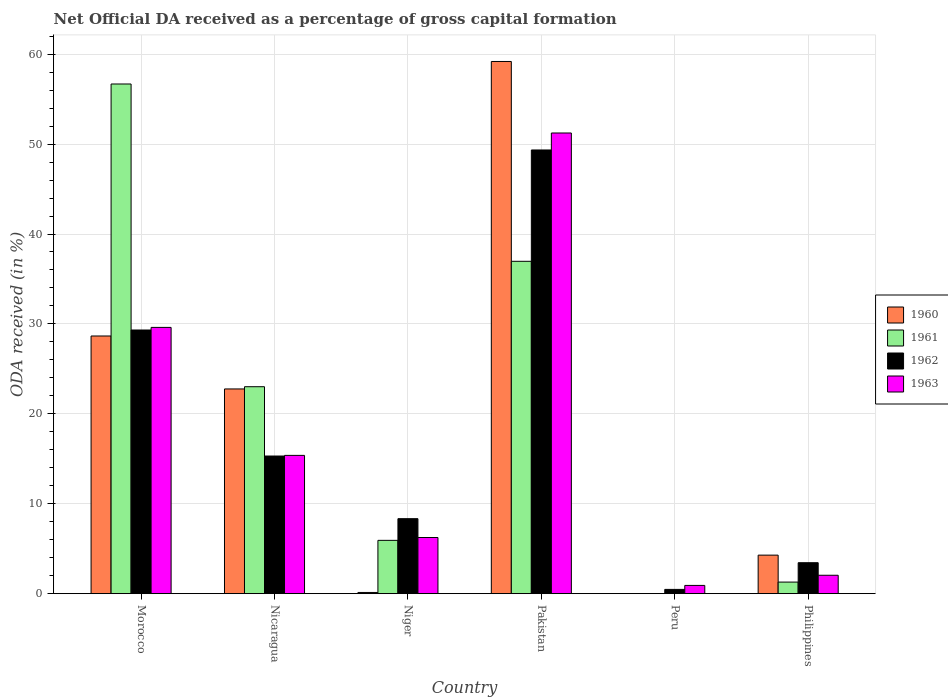How many different coloured bars are there?
Keep it short and to the point. 4. How many groups of bars are there?
Offer a very short reply. 6. How many bars are there on the 6th tick from the left?
Give a very brief answer. 4. How many bars are there on the 5th tick from the right?
Offer a very short reply. 4. What is the label of the 6th group of bars from the left?
Your answer should be compact. Philippines. What is the net ODA received in 1963 in Peru?
Ensure brevity in your answer.  0.92. Across all countries, what is the maximum net ODA received in 1960?
Give a very brief answer. 59.19. Across all countries, what is the minimum net ODA received in 1963?
Give a very brief answer. 0.92. In which country was the net ODA received in 1961 maximum?
Ensure brevity in your answer.  Morocco. What is the total net ODA received in 1962 in the graph?
Your answer should be compact. 106.24. What is the difference between the net ODA received in 1962 in Morocco and that in Niger?
Offer a very short reply. 20.98. What is the difference between the net ODA received in 1960 in Morocco and the net ODA received in 1963 in Nicaragua?
Provide a short and direct response. 13.28. What is the average net ODA received in 1962 per country?
Offer a very short reply. 17.71. What is the difference between the net ODA received of/in 1963 and net ODA received of/in 1960 in Pakistan?
Keep it short and to the point. -7.95. What is the ratio of the net ODA received in 1960 in Nicaragua to that in Pakistan?
Provide a short and direct response. 0.38. Is the difference between the net ODA received in 1963 in Nicaragua and Philippines greater than the difference between the net ODA received in 1960 in Nicaragua and Philippines?
Offer a terse response. No. What is the difference between the highest and the second highest net ODA received in 1960?
Your answer should be very brief. 30.53. What is the difference between the highest and the lowest net ODA received in 1961?
Your answer should be very brief. 56.69. Is it the case that in every country, the sum of the net ODA received in 1960 and net ODA received in 1963 is greater than the sum of net ODA received in 1962 and net ODA received in 1961?
Your response must be concise. No. Are all the bars in the graph horizontal?
Provide a short and direct response. No. How many countries are there in the graph?
Your response must be concise. 6. Does the graph contain any zero values?
Your answer should be compact. Yes. How are the legend labels stacked?
Your response must be concise. Vertical. What is the title of the graph?
Offer a terse response. Net Official DA received as a percentage of gross capital formation. What is the label or title of the X-axis?
Offer a terse response. Country. What is the label or title of the Y-axis?
Provide a succinct answer. ODA received (in %). What is the ODA received (in %) in 1960 in Morocco?
Give a very brief answer. 28.66. What is the ODA received (in %) of 1961 in Morocco?
Offer a very short reply. 56.69. What is the ODA received (in %) of 1962 in Morocco?
Your answer should be compact. 29.32. What is the ODA received (in %) in 1963 in Morocco?
Keep it short and to the point. 29.61. What is the ODA received (in %) in 1960 in Nicaragua?
Your response must be concise. 22.77. What is the ODA received (in %) of 1961 in Nicaragua?
Offer a very short reply. 23.02. What is the ODA received (in %) in 1962 in Nicaragua?
Give a very brief answer. 15.31. What is the ODA received (in %) in 1963 in Nicaragua?
Give a very brief answer. 15.38. What is the ODA received (in %) in 1960 in Niger?
Offer a very short reply. 0.13. What is the ODA received (in %) of 1961 in Niger?
Provide a succinct answer. 5.93. What is the ODA received (in %) in 1962 in Niger?
Your answer should be compact. 8.34. What is the ODA received (in %) in 1963 in Niger?
Provide a short and direct response. 6.25. What is the ODA received (in %) of 1960 in Pakistan?
Make the answer very short. 59.19. What is the ODA received (in %) of 1961 in Pakistan?
Offer a terse response. 36.96. What is the ODA received (in %) in 1962 in Pakistan?
Provide a succinct answer. 49.35. What is the ODA received (in %) in 1963 in Pakistan?
Make the answer very short. 51.24. What is the ODA received (in %) in 1961 in Peru?
Provide a short and direct response. 0. What is the ODA received (in %) of 1962 in Peru?
Make the answer very short. 0.47. What is the ODA received (in %) of 1963 in Peru?
Your answer should be very brief. 0.92. What is the ODA received (in %) of 1960 in Philippines?
Make the answer very short. 4.28. What is the ODA received (in %) in 1961 in Philippines?
Offer a very short reply. 1.29. What is the ODA received (in %) in 1962 in Philippines?
Keep it short and to the point. 3.44. What is the ODA received (in %) in 1963 in Philippines?
Provide a succinct answer. 2.05. Across all countries, what is the maximum ODA received (in %) in 1960?
Provide a succinct answer. 59.19. Across all countries, what is the maximum ODA received (in %) of 1961?
Give a very brief answer. 56.69. Across all countries, what is the maximum ODA received (in %) of 1962?
Your answer should be compact. 49.35. Across all countries, what is the maximum ODA received (in %) in 1963?
Offer a very short reply. 51.24. Across all countries, what is the minimum ODA received (in %) in 1960?
Offer a terse response. 0. Across all countries, what is the minimum ODA received (in %) of 1961?
Ensure brevity in your answer.  0. Across all countries, what is the minimum ODA received (in %) in 1962?
Make the answer very short. 0.47. Across all countries, what is the minimum ODA received (in %) of 1963?
Provide a succinct answer. 0.92. What is the total ODA received (in %) of 1960 in the graph?
Make the answer very short. 115.03. What is the total ODA received (in %) of 1961 in the graph?
Make the answer very short. 123.88. What is the total ODA received (in %) in 1962 in the graph?
Provide a succinct answer. 106.24. What is the total ODA received (in %) in 1963 in the graph?
Your answer should be very brief. 105.44. What is the difference between the ODA received (in %) of 1960 in Morocco and that in Nicaragua?
Provide a short and direct response. 5.89. What is the difference between the ODA received (in %) in 1961 in Morocco and that in Nicaragua?
Give a very brief answer. 33.67. What is the difference between the ODA received (in %) in 1962 in Morocco and that in Nicaragua?
Ensure brevity in your answer.  14.02. What is the difference between the ODA received (in %) of 1963 in Morocco and that in Nicaragua?
Provide a short and direct response. 14.23. What is the difference between the ODA received (in %) in 1960 in Morocco and that in Niger?
Ensure brevity in your answer.  28.52. What is the difference between the ODA received (in %) of 1961 in Morocco and that in Niger?
Offer a terse response. 50.76. What is the difference between the ODA received (in %) in 1962 in Morocco and that in Niger?
Provide a short and direct response. 20.98. What is the difference between the ODA received (in %) of 1963 in Morocco and that in Niger?
Your answer should be very brief. 23.37. What is the difference between the ODA received (in %) in 1960 in Morocco and that in Pakistan?
Offer a terse response. -30.53. What is the difference between the ODA received (in %) in 1961 in Morocco and that in Pakistan?
Provide a short and direct response. 19.72. What is the difference between the ODA received (in %) in 1962 in Morocco and that in Pakistan?
Offer a very short reply. -20.02. What is the difference between the ODA received (in %) of 1963 in Morocco and that in Pakistan?
Ensure brevity in your answer.  -21.62. What is the difference between the ODA received (in %) in 1962 in Morocco and that in Peru?
Your answer should be compact. 28.85. What is the difference between the ODA received (in %) in 1963 in Morocco and that in Peru?
Your answer should be compact. 28.7. What is the difference between the ODA received (in %) in 1960 in Morocco and that in Philippines?
Provide a succinct answer. 24.37. What is the difference between the ODA received (in %) in 1961 in Morocco and that in Philippines?
Give a very brief answer. 55.4. What is the difference between the ODA received (in %) in 1962 in Morocco and that in Philippines?
Offer a very short reply. 25.88. What is the difference between the ODA received (in %) of 1963 in Morocco and that in Philippines?
Keep it short and to the point. 27.57. What is the difference between the ODA received (in %) of 1960 in Nicaragua and that in Niger?
Offer a terse response. 22.64. What is the difference between the ODA received (in %) in 1961 in Nicaragua and that in Niger?
Your response must be concise. 17.09. What is the difference between the ODA received (in %) of 1962 in Nicaragua and that in Niger?
Offer a very short reply. 6.97. What is the difference between the ODA received (in %) in 1963 in Nicaragua and that in Niger?
Your response must be concise. 9.13. What is the difference between the ODA received (in %) of 1960 in Nicaragua and that in Pakistan?
Make the answer very short. -36.42. What is the difference between the ODA received (in %) in 1961 in Nicaragua and that in Pakistan?
Give a very brief answer. -13.95. What is the difference between the ODA received (in %) in 1962 in Nicaragua and that in Pakistan?
Your response must be concise. -34.04. What is the difference between the ODA received (in %) of 1963 in Nicaragua and that in Pakistan?
Provide a succinct answer. -35.86. What is the difference between the ODA received (in %) of 1962 in Nicaragua and that in Peru?
Ensure brevity in your answer.  14.83. What is the difference between the ODA received (in %) in 1963 in Nicaragua and that in Peru?
Offer a very short reply. 14.46. What is the difference between the ODA received (in %) in 1960 in Nicaragua and that in Philippines?
Offer a terse response. 18.48. What is the difference between the ODA received (in %) in 1961 in Nicaragua and that in Philippines?
Ensure brevity in your answer.  21.73. What is the difference between the ODA received (in %) of 1962 in Nicaragua and that in Philippines?
Offer a very short reply. 11.87. What is the difference between the ODA received (in %) of 1963 in Nicaragua and that in Philippines?
Make the answer very short. 13.33. What is the difference between the ODA received (in %) in 1960 in Niger and that in Pakistan?
Give a very brief answer. -59.06. What is the difference between the ODA received (in %) in 1961 in Niger and that in Pakistan?
Ensure brevity in your answer.  -31.03. What is the difference between the ODA received (in %) in 1962 in Niger and that in Pakistan?
Make the answer very short. -41.01. What is the difference between the ODA received (in %) of 1963 in Niger and that in Pakistan?
Make the answer very short. -44.99. What is the difference between the ODA received (in %) in 1962 in Niger and that in Peru?
Provide a succinct answer. 7.87. What is the difference between the ODA received (in %) of 1963 in Niger and that in Peru?
Ensure brevity in your answer.  5.33. What is the difference between the ODA received (in %) of 1960 in Niger and that in Philippines?
Provide a succinct answer. -4.15. What is the difference between the ODA received (in %) in 1961 in Niger and that in Philippines?
Your response must be concise. 4.64. What is the difference between the ODA received (in %) of 1962 in Niger and that in Philippines?
Provide a short and direct response. 4.9. What is the difference between the ODA received (in %) of 1963 in Niger and that in Philippines?
Provide a succinct answer. 4.2. What is the difference between the ODA received (in %) in 1962 in Pakistan and that in Peru?
Provide a short and direct response. 48.87. What is the difference between the ODA received (in %) of 1963 in Pakistan and that in Peru?
Keep it short and to the point. 50.32. What is the difference between the ODA received (in %) in 1960 in Pakistan and that in Philippines?
Give a very brief answer. 54.9. What is the difference between the ODA received (in %) in 1961 in Pakistan and that in Philippines?
Provide a short and direct response. 35.68. What is the difference between the ODA received (in %) of 1962 in Pakistan and that in Philippines?
Keep it short and to the point. 45.91. What is the difference between the ODA received (in %) in 1963 in Pakistan and that in Philippines?
Keep it short and to the point. 49.19. What is the difference between the ODA received (in %) of 1962 in Peru and that in Philippines?
Keep it short and to the point. -2.97. What is the difference between the ODA received (in %) of 1963 in Peru and that in Philippines?
Your answer should be very brief. -1.13. What is the difference between the ODA received (in %) of 1960 in Morocco and the ODA received (in %) of 1961 in Nicaragua?
Your answer should be compact. 5.64. What is the difference between the ODA received (in %) of 1960 in Morocco and the ODA received (in %) of 1962 in Nicaragua?
Your answer should be compact. 13.35. What is the difference between the ODA received (in %) of 1960 in Morocco and the ODA received (in %) of 1963 in Nicaragua?
Give a very brief answer. 13.28. What is the difference between the ODA received (in %) in 1961 in Morocco and the ODA received (in %) in 1962 in Nicaragua?
Provide a short and direct response. 41.38. What is the difference between the ODA received (in %) in 1961 in Morocco and the ODA received (in %) in 1963 in Nicaragua?
Make the answer very short. 41.31. What is the difference between the ODA received (in %) of 1962 in Morocco and the ODA received (in %) of 1963 in Nicaragua?
Make the answer very short. 13.95. What is the difference between the ODA received (in %) of 1960 in Morocco and the ODA received (in %) of 1961 in Niger?
Provide a short and direct response. 22.73. What is the difference between the ODA received (in %) of 1960 in Morocco and the ODA received (in %) of 1962 in Niger?
Offer a terse response. 20.32. What is the difference between the ODA received (in %) of 1960 in Morocco and the ODA received (in %) of 1963 in Niger?
Offer a terse response. 22.41. What is the difference between the ODA received (in %) in 1961 in Morocco and the ODA received (in %) in 1962 in Niger?
Your response must be concise. 48.35. What is the difference between the ODA received (in %) of 1961 in Morocco and the ODA received (in %) of 1963 in Niger?
Offer a terse response. 50.44. What is the difference between the ODA received (in %) of 1962 in Morocco and the ODA received (in %) of 1963 in Niger?
Offer a terse response. 23.08. What is the difference between the ODA received (in %) in 1960 in Morocco and the ODA received (in %) in 1961 in Pakistan?
Offer a terse response. -8.31. What is the difference between the ODA received (in %) in 1960 in Morocco and the ODA received (in %) in 1962 in Pakistan?
Keep it short and to the point. -20.69. What is the difference between the ODA received (in %) in 1960 in Morocco and the ODA received (in %) in 1963 in Pakistan?
Provide a succinct answer. -22.58. What is the difference between the ODA received (in %) of 1961 in Morocco and the ODA received (in %) of 1962 in Pakistan?
Ensure brevity in your answer.  7.34. What is the difference between the ODA received (in %) in 1961 in Morocco and the ODA received (in %) in 1963 in Pakistan?
Offer a very short reply. 5.45. What is the difference between the ODA received (in %) of 1962 in Morocco and the ODA received (in %) of 1963 in Pakistan?
Offer a terse response. -21.91. What is the difference between the ODA received (in %) of 1960 in Morocco and the ODA received (in %) of 1962 in Peru?
Offer a terse response. 28.18. What is the difference between the ODA received (in %) of 1960 in Morocco and the ODA received (in %) of 1963 in Peru?
Your answer should be very brief. 27.74. What is the difference between the ODA received (in %) in 1961 in Morocco and the ODA received (in %) in 1962 in Peru?
Make the answer very short. 56.21. What is the difference between the ODA received (in %) in 1961 in Morocco and the ODA received (in %) in 1963 in Peru?
Your answer should be very brief. 55.77. What is the difference between the ODA received (in %) of 1962 in Morocco and the ODA received (in %) of 1963 in Peru?
Your response must be concise. 28.41. What is the difference between the ODA received (in %) of 1960 in Morocco and the ODA received (in %) of 1961 in Philippines?
Keep it short and to the point. 27.37. What is the difference between the ODA received (in %) in 1960 in Morocco and the ODA received (in %) in 1962 in Philippines?
Keep it short and to the point. 25.22. What is the difference between the ODA received (in %) of 1960 in Morocco and the ODA received (in %) of 1963 in Philippines?
Your response must be concise. 26.61. What is the difference between the ODA received (in %) of 1961 in Morocco and the ODA received (in %) of 1962 in Philippines?
Your answer should be compact. 53.24. What is the difference between the ODA received (in %) in 1961 in Morocco and the ODA received (in %) in 1963 in Philippines?
Make the answer very short. 54.64. What is the difference between the ODA received (in %) of 1962 in Morocco and the ODA received (in %) of 1963 in Philippines?
Ensure brevity in your answer.  27.28. What is the difference between the ODA received (in %) in 1960 in Nicaragua and the ODA received (in %) in 1961 in Niger?
Offer a terse response. 16.84. What is the difference between the ODA received (in %) of 1960 in Nicaragua and the ODA received (in %) of 1962 in Niger?
Provide a short and direct response. 14.43. What is the difference between the ODA received (in %) of 1960 in Nicaragua and the ODA received (in %) of 1963 in Niger?
Your response must be concise. 16.52. What is the difference between the ODA received (in %) in 1961 in Nicaragua and the ODA received (in %) in 1962 in Niger?
Make the answer very short. 14.68. What is the difference between the ODA received (in %) in 1961 in Nicaragua and the ODA received (in %) in 1963 in Niger?
Your response must be concise. 16.77. What is the difference between the ODA received (in %) of 1962 in Nicaragua and the ODA received (in %) of 1963 in Niger?
Your answer should be very brief. 9.06. What is the difference between the ODA received (in %) in 1960 in Nicaragua and the ODA received (in %) in 1961 in Pakistan?
Offer a very short reply. -14.2. What is the difference between the ODA received (in %) in 1960 in Nicaragua and the ODA received (in %) in 1962 in Pakistan?
Keep it short and to the point. -26.58. What is the difference between the ODA received (in %) of 1960 in Nicaragua and the ODA received (in %) of 1963 in Pakistan?
Offer a terse response. -28.47. What is the difference between the ODA received (in %) of 1961 in Nicaragua and the ODA received (in %) of 1962 in Pakistan?
Provide a succinct answer. -26.33. What is the difference between the ODA received (in %) of 1961 in Nicaragua and the ODA received (in %) of 1963 in Pakistan?
Keep it short and to the point. -28.22. What is the difference between the ODA received (in %) of 1962 in Nicaragua and the ODA received (in %) of 1963 in Pakistan?
Offer a terse response. -35.93. What is the difference between the ODA received (in %) in 1960 in Nicaragua and the ODA received (in %) in 1962 in Peru?
Ensure brevity in your answer.  22.29. What is the difference between the ODA received (in %) of 1960 in Nicaragua and the ODA received (in %) of 1963 in Peru?
Make the answer very short. 21.85. What is the difference between the ODA received (in %) in 1961 in Nicaragua and the ODA received (in %) in 1962 in Peru?
Your answer should be very brief. 22.54. What is the difference between the ODA received (in %) of 1961 in Nicaragua and the ODA received (in %) of 1963 in Peru?
Your answer should be compact. 22.1. What is the difference between the ODA received (in %) of 1962 in Nicaragua and the ODA received (in %) of 1963 in Peru?
Your answer should be compact. 14.39. What is the difference between the ODA received (in %) of 1960 in Nicaragua and the ODA received (in %) of 1961 in Philippines?
Keep it short and to the point. 21.48. What is the difference between the ODA received (in %) in 1960 in Nicaragua and the ODA received (in %) in 1962 in Philippines?
Your response must be concise. 19.33. What is the difference between the ODA received (in %) in 1960 in Nicaragua and the ODA received (in %) in 1963 in Philippines?
Offer a terse response. 20.72. What is the difference between the ODA received (in %) of 1961 in Nicaragua and the ODA received (in %) of 1962 in Philippines?
Make the answer very short. 19.58. What is the difference between the ODA received (in %) in 1961 in Nicaragua and the ODA received (in %) in 1963 in Philippines?
Your answer should be compact. 20.97. What is the difference between the ODA received (in %) in 1962 in Nicaragua and the ODA received (in %) in 1963 in Philippines?
Give a very brief answer. 13.26. What is the difference between the ODA received (in %) of 1960 in Niger and the ODA received (in %) of 1961 in Pakistan?
Your response must be concise. -36.83. What is the difference between the ODA received (in %) in 1960 in Niger and the ODA received (in %) in 1962 in Pakistan?
Give a very brief answer. -49.21. What is the difference between the ODA received (in %) of 1960 in Niger and the ODA received (in %) of 1963 in Pakistan?
Keep it short and to the point. -51.1. What is the difference between the ODA received (in %) in 1961 in Niger and the ODA received (in %) in 1962 in Pakistan?
Your answer should be compact. -43.42. What is the difference between the ODA received (in %) in 1961 in Niger and the ODA received (in %) in 1963 in Pakistan?
Make the answer very short. -45.31. What is the difference between the ODA received (in %) of 1962 in Niger and the ODA received (in %) of 1963 in Pakistan?
Provide a succinct answer. -42.9. What is the difference between the ODA received (in %) of 1960 in Niger and the ODA received (in %) of 1962 in Peru?
Offer a very short reply. -0.34. What is the difference between the ODA received (in %) of 1960 in Niger and the ODA received (in %) of 1963 in Peru?
Ensure brevity in your answer.  -0.78. What is the difference between the ODA received (in %) of 1961 in Niger and the ODA received (in %) of 1962 in Peru?
Your answer should be very brief. 5.46. What is the difference between the ODA received (in %) of 1961 in Niger and the ODA received (in %) of 1963 in Peru?
Offer a terse response. 5.01. What is the difference between the ODA received (in %) of 1962 in Niger and the ODA received (in %) of 1963 in Peru?
Keep it short and to the point. 7.42. What is the difference between the ODA received (in %) of 1960 in Niger and the ODA received (in %) of 1961 in Philippines?
Your answer should be compact. -1.15. What is the difference between the ODA received (in %) in 1960 in Niger and the ODA received (in %) in 1962 in Philippines?
Keep it short and to the point. -3.31. What is the difference between the ODA received (in %) of 1960 in Niger and the ODA received (in %) of 1963 in Philippines?
Provide a short and direct response. -1.91. What is the difference between the ODA received (in %) in 1961 in Niger and the ODA received (in %) in 1962 in Philippines?
Offer a very short reply. 2.49. What is the difference between the ODA received (in %) of 1961 in Niger and the ODA received (in %) of 1963 in Philippines?
Your answer should be compact. 3.88. What is the difference between the ODA received (in %) in 1962 in Niger and the ODA received (in %) in 1963 in Philippines?
Offer a very short reply. 6.29. What is the difference between the ODA received (in %) in 1960 in Pakistan and the ODA received (in %) in 1962 in Peru?
Your response must be concise. 58.71. What is the difference between the ODA received (in %) in 1960 in Pakistan and the ODA received (in %) in 1963 in Peru?
Offer a very short reply. 58.27. What is the difference between the ODA received (in %) in 1961 in Pakistan and the ODA received (in %) in 1962 in Peru?
Your answer should be very brief. 36.49. What is the difference between the ODA received (in %) of 1961 in Pakistan and the ODA received (in %) of 1963 in Peru?
Provide a short and direct response. 36.05. What is the difference between the ODA received (in %) in 1962 in Pakistan and the ODA received (in %) in 1963 in Peru?
Ensure brevity in your answer.  48.43. What is the difference between the ODA received (in %) in 1960 in Pakistan and the ODA received (in %) in 1961 in Philippines?
Ensure brevity in your answer.  57.9. What is the difference between the ODA received (in %) of 1960 in Pakistan and the ODA received (in %) of 1962 in Philippines?
Give a very brief answer. 55.75. What is the difference between the ODA received (in %) in 1960 in Pakistan and the ODA received (in %) in 1963 in Philippines?
Offer a very short reply. 57.14. What is the difference between the ODA received (in %) of 1961 in Pakistan and the ODA received (in %) of 1962 in Philippines?
Provide a succinct answer. 33.52. What is the difference between the ODA received (in %) of 1961 in Pakistan and the ODA received (in %) of 1963 in Philippines?
Offer a very short reply. 34.92. What is the difference between the ODA received (in %) of 1962 in Pakistan and the ODA received (in %) of 1963 in Philippines?
Offer a terse response. 47.3. What is the difference between the ODA received (in %) in 1962 in Peru and the ODA received (in %) in 1963 in Philippines?
Your answer should be compact. -1.57. What is the average ODA received (in %) in 1960 per country?
Offer a terse response. 19.17. What is the average ODA received (in %) of 1961 per country?
Ensure brevity in your answer.  20.65. What is the average ODA received (in %) in 1962 per country?
Keep it short and to the point. 17.71. What is the average ODA received (in %) in 1963 per country?
Provide a short and direct response. 17.57. What is the difference between the ODA received (in %) in 1960 and ODA received (in %) in 1961 in Morocco?
Offer a very short reply. -28.03. What is the difference between the ODA received (in %) of 1960 and ODA received (in %) of 1962 in Morocco?
Keep it short and to the point. -0.67. What is the difference between the ODA received (in %) of 1960 and ODA received (in %) of 1963 in Morocco?
Ensure brevity in your answer.  -0.96. What is the difference between the ODA received (in %) in 1961 and ODA received (in %) in 1962 in Morocco?
Your response must be concise. 27.36. What is the difference between the ODA received (in %) of 1961 and ODA received (in %) of 1963 in Morocco?
Your response must be concise. 27.07. What is the difference between the ODA received (in %) of 1962 and ODA received (in %) of 1963 in Morocco?
Your answer should be compact. -0.29. What is the difference between the ODA received (in %) of 1960 and ODA received (in %) of 1961 in Nicaragua?
Keep it short and to the point. -0.25. What is the difference between the ODA received (in %) in 1960 and ODA received (in %) in 1962 in Nicaragua?
Keep it short and to the point. 7.46. What is the difference between the ODA received (in %) of 1960 and ODA received (in %) of 1963 in Nicaragua?
Make the answer very short. 7.39. What is the difference between the ODA received (in %) of 1961 and ODA received (in %) of 1962 in Nicaragua?
Make the answer very short. 7.71. What is the difference between the ODA received (in %) in 1961 and ODA received (in %) in 1963 in Nicaragua?
Your answer should be very brief. 7.64. What is the difference between the ODA received (in %) of 1962 and ODA received (in %) of 1963 in Nicaragua?
Your response must be concise. -0.07. What is the difference between the ODA received (in %) in 1960 and ODA received (in %) in 1961 in Niger?
Provide a short and direct response. -5.8. What is the difference between the ODA received (in %) in 1960 and ODA received (in %) in 1962 in Niger?
Offer a very short reply. -8.21. What is the difference between the ODA received (in %) of 1960 and ODA received (in %) of 1963 in Niger?
Offer a very short reply. -6.11. What is the difference between the ODA received (in %) in 1961 and ODA received (in %) in 1962 in Niger?
Offer a very short reply. -2.41. What is the difference between the ODA received (in %) in 1961 and ODA received (in %) in 1963 in Niger?
Make the answer very short. -0.32. What is the difference between the ODA received (in %) in 1962 and ODA received (in %) in 1963 in Niger?
Make the answer very short. 2.09. What is the difference between the ODA received (in %) of 1960 and ODA received (in %) of 1961 in Pakistan?
Offer a terse response. 22.22. What is the difference between the ODA received (in %) of 1960 and ODA received (in %) of 1962 in Pakistan?
Keep it short and to the point. 9.84. What is the difference between the ODA received (in %) of 1960 and ODA received (in %) of 1963 in Pakistan?
Your answer should be very brief. 7.95. What is the difference between the ODA received (in %) of 1961 and ODA received (in %) of 1962 in Pakistan?
Give a very brief answer. -12.38. What is the difference between the ODA received (in %) in 1961 and ODA received (in %) in 1963 in Pakistan?
Keep it short and to the point. -14.27. What is the difference between the ODA received (in %) of 1962 and ODA received (in %) of 1963 in Pakistan?
Provide a short and direct response. -1.89. What is the difference between the ODA received (in %) of 1962 and ODA received (in %) of 1963 in Peru?
Provide a short and direct response. -0.44. What is the difference between the ODA received (in %) in 1960 and ODA received (in %) in 1961 in Philippines?
Give a very brief answer. 3. What is the difference between the ODA received (in %) in 1960 and ODA received (in %) in 1962 in Philippines?
Give a very brief answer. 0.84. What is the difference between the ODA received (in %) of 1960 and ODA received (in %) of 1963 in Philippines?
Provide a succinct answer. 2.24. What is the difference between the ODA received (in %) in 1961 and ODA received (in %) in 1962 in Philippines?
Your answer should be compact. -2.15. What is the difference between the ODA received (in %) of 1961 and ODA received (in %) of 1963 in Philippines?
Provide a short and direct response. -0.76. What is the difference between the ODA received (in %) of 1962 and ODA received (in %) of 1963 in Philippines?
Offer a very short reply. 1.4. What is the ratio of the ODA received (in %) of 1960 in Morocco to that in Nicaragua?
Provide a short and direct response. 1.26. What is the ratio of the ODA received (in %) of 1961 in Morocco to that in Nicaragua?
Give a very brief answer. 2.46. What is the ratio of the ODA received (in %) in 1962 in Morocco to that in Nicaragua?
Make the answer very short. 1.92. What is the ratio of the ODA received (in %) of 1963 in Morocco to that in Nicaragua?
Make the answer very short. 1.93. What is the ratio of the ODA received (in %) of 1960 in Morocco to that in Niger?
Provide a short and direct response. 215.63. What is the ratio of the ODA received (in %) of 1961 in Morocco to that in Niger?
Offer a very short reply. 9.56. What is the ratio of the ODA received (in %) in 1962 in Morocco to that in Niger?
Your answer should be compact. 3.52. What is the ratio of the ODA received (in %) of 1963 in Morocco to that in Niger?
Your answer should be very brief. 4.74. What is the ratio of the ODA received (in %) of 1960 in Morocco to that in Pakistan?
Offer a terse response. 0.48. What is the ratio of the ODA received (in %) of 1961 in Morocco to that in Pakistan?
Keep it short and to the point. 1.53. What is the ratio of the ODA received (in %) of 1962 in Morocco to that in Pakistan?
Keep it short and to the point. 0.59. What is the ratio of the ODA received (in %) in 1963 in Morocco to that in Pakistan?
Give a very brief answer. 0.58. What is the ratio of the ODA received (in %) in 1962 in Morocco to that in Peru?
Ensure brevity in your answer.  61.84. What is the ratio of the ODA received (in %) in 1963 in Morocco to that in Peru?
Keep it short and to the point. 32.28. What is the ratio of the ODA received (in %) of 1960 in Morocco to that in Philippines?
Provide a short and direct response. 6.69. What is the ratio of the ODA received (in %) in 1961 in Morocco to that in Philippines?
Ensure brevity in your answer.  44.03. What is the ratio of the ODA received (in %) in 1962 in Morocco to that in Philippines?
Your answer should be very brief. 8.52. What is the ratio of the ODA received (in %) of 1963 in Morocco to that in Philippines?
Your answer should be compact. 14.47. What is the ratio of the ODA received (in %) of 1960 in Nicaragua to that in Niger?
Provide a succinct answer. 171.32. What is the ratio of the ODA received (in %) of 1961 in Nicaragua to that in Niger?
Provide a succinct answer. 3.88. What is the ratio of the ODA received (in %) in 1962 in Nicaragua to that in Niger?
Your answer should be very brief. 1.84. What is the ratio of the ODA received (in %) of 1963 in Nicaragua to that in Niger?
Your response must be concise. 2.46. What is the ratio of the ODA received (in %) of 1960 in Nicaragua to that in Pakistan?
Give a very brief answer. 0.38. What is the ratio of the ODA received (in %) in 1961 in Nicaragua to that in Pakistan?
Offer a terse response. 0.62. What is the ratio of the ODA received (in %) of 1962 in Nicaragua to that in Pakistan?
Your answer should be compact. 0.31. What is the ratio of the ODA received (in %) of 1963 in Nicaragua to that in Pakistan?
Provide a short and direct response. 0.3. What is the ratio of the ODA received (in %) of 1962 in Nicaragua to that in Peru?
Keep it short and to the point. 32.28. What is the ratio of the ODA received (in %) of 1963 in Nicaragua to that in Peru?
Ensure brevity in your answer.  16.76. What is the ratio of the ODA received (in %) in 1960 in Nicaragua to that in Philippines?
Provide a succinct answer. 5.31. What is the ratio of the ODA received (in %) in 1961 in Nicaragua to that in Philippines?
Give a very brief answer. 17.88. What is the ratio of the ODA received (in %) of 1962 in Nicaragua to that in Philippines?
Offer a very short reply. 4.45. What is the ratio of the ODA received (in %) in 1963 in Nicaragua to that in Philippines?
Give a very brief answer. 7.52. What is the ratio of the ODA received (in %) of 1960 in Niger to that in Pakistan?
Provide a succinct answer. 0. What is the ratio of the ODA received (in %) of 1961 in Niger to that in Pakistan?
Give a very brief answer. 0.16. What is the ratio of the ODA received (in %) in 1962 in Niger to that in Pakistan?
Provide a short and direct response. 0.17. What is the ratio of the ODA received (in %) in 1963 in Niger to that in Pakistan?
Offer a very short reply. 0.12. What is the ratio of the ODA received (in %) of 1962 in Niger to that in Peru?
Provide a short and direct response. 17.59. What is the ratio of the ODA received (in %) of 1963 in Niger to that in Peru?
Ensure brevity in your answer.  6.81. What is the ratio of the ODA received (in %) in 1960 in Niger to that in Philippines?
Offer a terse response. 0.03. What is the ratio of the ODA received (in %) in 1961 in Niger to that in Philippines?
Your answer should be very brief. 4.61. What is the ratio of the ODA received (in %) in 1962 in Niger to that in Philippines?
Ensure brevity in your answer.  2.42. What is the ratio of the ODA received (in %) in 1963 in Niger to that in Philippines?
Make the answer very short. 3.05. What is the ratio of the ODA received (in %) of 1962 in Pakistan to that in Peru?
Provide a succinct answer. 104.06. What is the ratio of the ODA received (in %) in 1963 in Pakistan to that in Peru?
Offer a terse response. 55.85. What is the ratio of the ODA received (in %) in 1960 in Pakistan to that in Philippines?
Make the answer very short. 13.82. What is the ratio of the ODA received (in %) in 1961 in Pakistan to that in Philippines?
Make the answer very short. 28.71. What is the ratio of the ODA received (in %) in 1962 in Pakistan to that in Philippines?
Give a very brief answer. 14.34. What is the ratio of the ODA received (in %) in 1963 in Pakistan to that in Philippines?
Offer a terse response. 25.04. What is the ratio of the ODA received (in %) in 1962 in Peru to that in Philippines?
Give a very brief answer. 0.14. What is the ratio of the ODA received (in %) in 1963 in Peru to that in Philippines?
Your answer should be very brief. 0.45. What is the difference between the highest and the second highest ODA received (in %) of 1960?
Provide a succinct answer. 30.53. What is the difference between the highest and the second highest ODA received (in %) of 1961?
Make the answer very short. 19.72. What is the difference between the highest and the second highest ODA received (in %) of 1962?
Keep it short and to the point. 20.02. What is the difference between the highest and the second highest ODA received (in %) of 1963?
Ensure brevity in your answer.  21.62. What is the difference between the highest and the lowest ODA received (in %) in 1960?
Your response must be concise. 59.19. What is the difference between the highest and the lowest ODA received (in %) of 1961?
Keep it short and to the point. 56.69. What is the difference between the highest and the lowest ODA received (in %) of 1962?
Keep it short and to the point. 48.87. What is the difference between the highest and the lowest ODA received (in %) in 1963?
Provide a short and direct response. 50.32. 